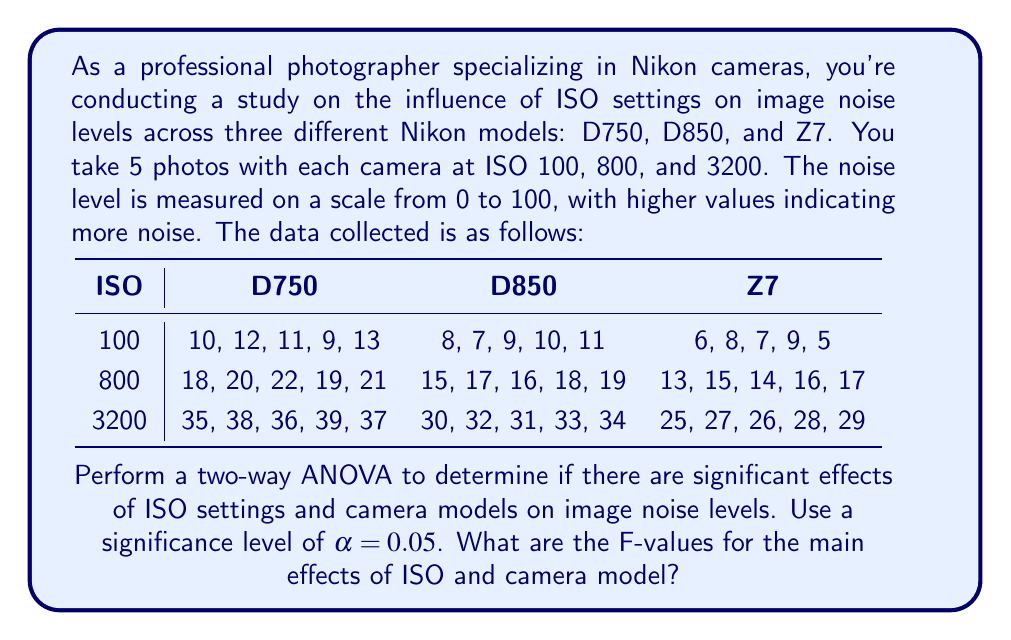Show me your answer to this math problem. To perform a two-way ANOVA, we need to calculate the following:

1. Sum of Squares (SS) for ISO, camera model, interaction, and error
2. Degrees of freedom (df) for each source of variation
3. Mean Square (MS) for each source
4. F-values for ISO and camera model effects

Step 1: Calculate the total sum of squares (SST)
First, calculate the grand mean and SST:

Grand mean = $\frac{\text{Sum of all observations}}{\text{Total number of observations}} = 20.6$

SST = $\sum (x_i - \bar{x})^2 = 8901.8$

Step 2: Calculate SS for ISO (SSA)
$$SSA = n_r n_c \sum_{i=1}^a (\bar{x}_{i.} - \bar{x})^2$$
Where $n_r$ is the number of replications (5) and $n_c$ is the number of camera models (3).
SSA = 8145.8

Step 3: Calculate SS for camera model (SSB)
$$SSB = n_r n_i \sum_{j=1}^b (\bar{x}_{.j} - \bar{x})^2$$
Where $n_i$ is the number of ISO levels (3).
SSB = 510.8

Step 4: Calculate SS for interaction (SSAB)
$$SSAB = n_r \sum_{i=1}^a \sum_{j=1}^b (\bar{x}_{ij} - \bar{x}_{i.} - \bar{x}_{.j} + \bar{x})^2$$
SSAB = 20.2

Step 5: Calculate SS for error (SSE)
SSE = SST - SSA - SSB - SSAB = 225

Step 6: Calculate degrees of freedom
df(ISO) = 2
df(Camera) = 2
df(Interaction) = 4
df(Error) = 36
df(Total) = 44

Step 7: Calculate Mean Squares
MS(ISO) = SSA / df(ISO) = 4072.9
MS(Camera) = SSB / df(Camera) = 255.4
MS(Interaction) = SSAB / df(Interaction) = 5.05
MS(Error) = SSE / df(Error) = 6.25

Step 8: Calculate F-values
F(ISO) = MS(ISO) / MS(Error) = 651.664
F(Camera) = MS(Camera) / MS(Error) = 40.864
Answer: The F-values for the main effects are:

ISO: F = 651.664
Camera model: F = 40.864 